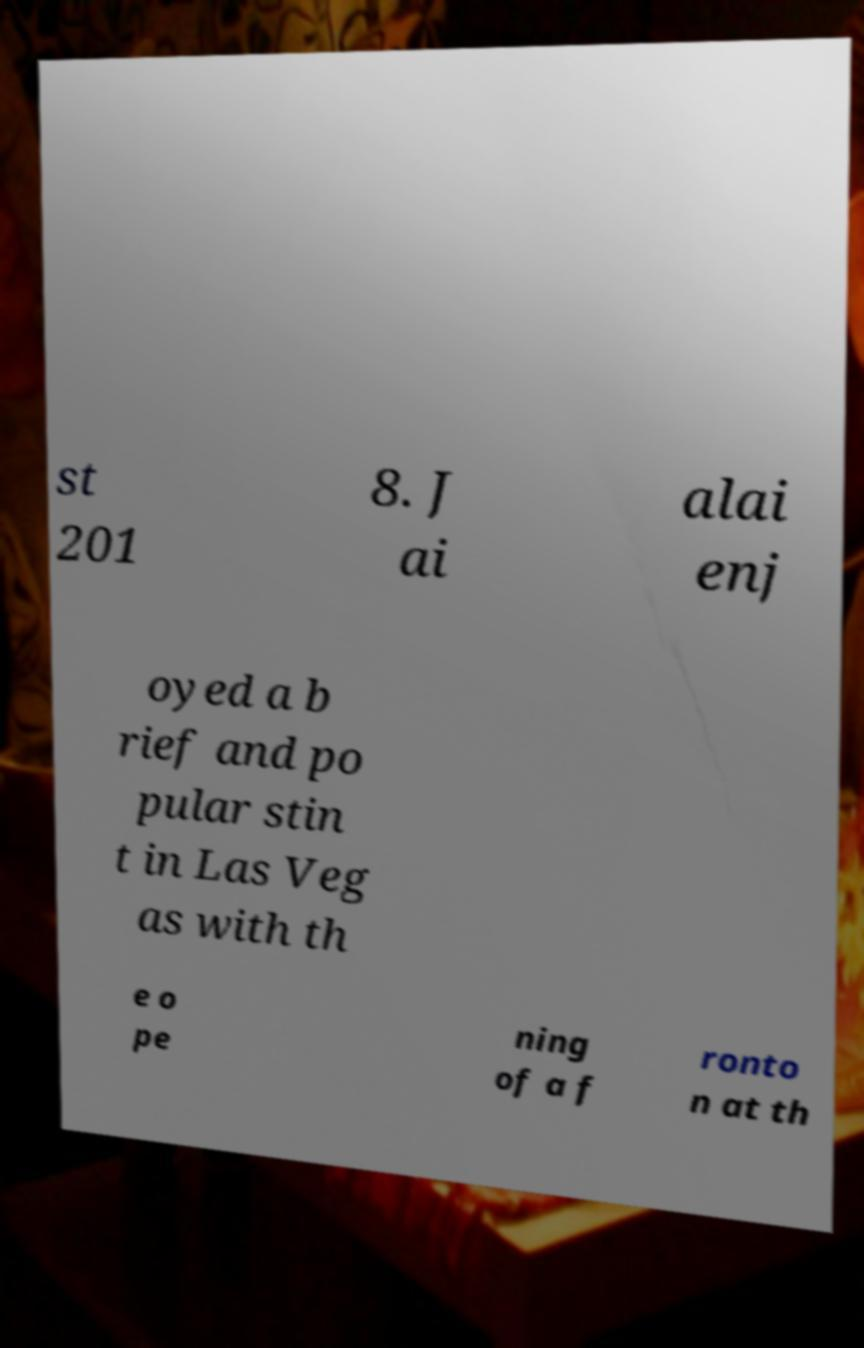Can you read and provide the text displayed in the image?This photo seems to have some interesting text. Can you extract and type it out for me? st 201 8. J ai alai enj oyed a b rief and po pular stin t in Las Veg as with th e o pe ning of a f ronto n at th 